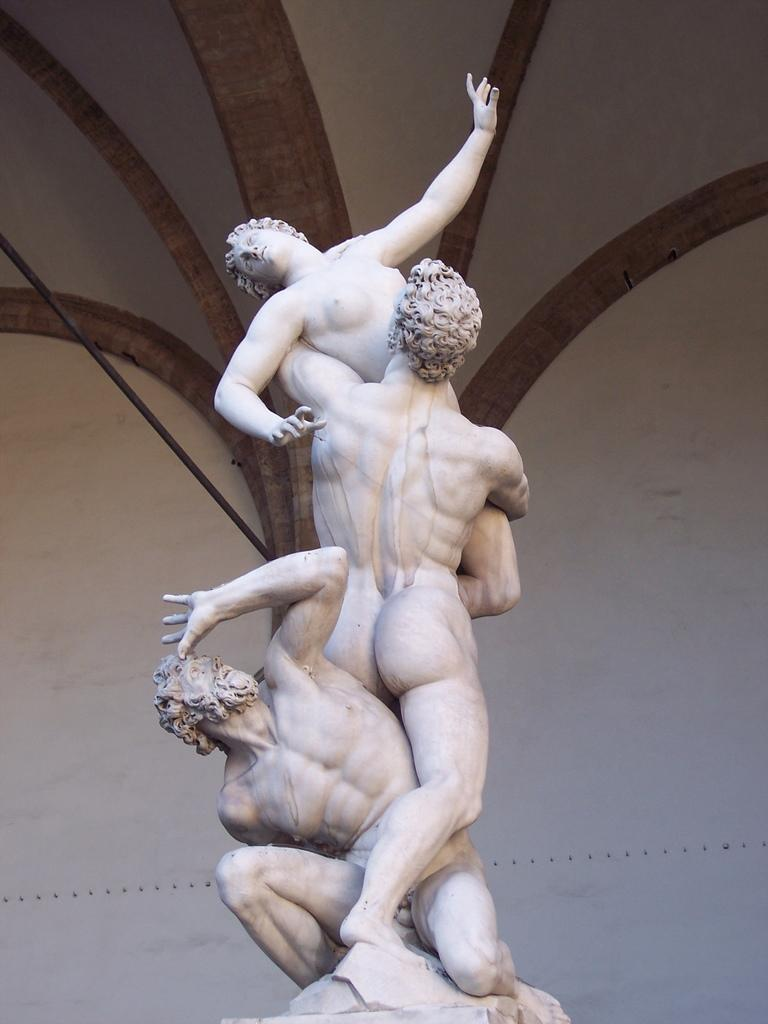What type of objects are in the image? There are people statues in the image. What color are the statues? The statues are white in color. What colors can be seen in the background of the image? The background of the image has white and brown colors. What type of baseball punishment is being depicted in the image? There is no baseball or punishment depicted in the image; it features people statues. What type of line is visible in the image? There is no line visible in the image. 